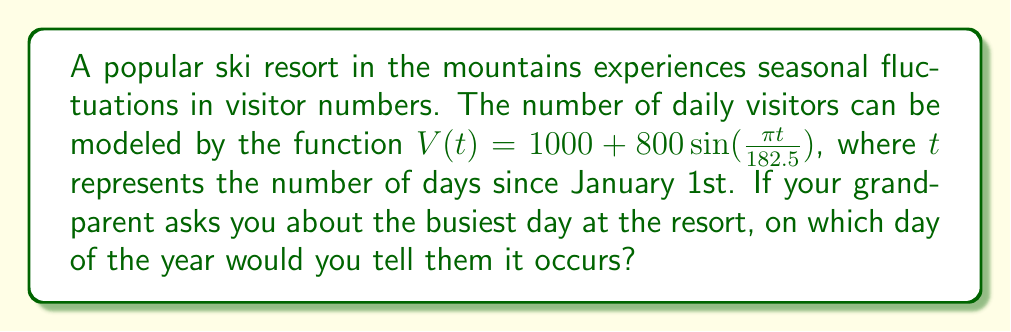Show me your answer to this math problem. To find the busiest day, we need to determine when the function $V(t)$ reaches its maximum value. Let's approach this step-by-step:

1) The sine function reaches its maximum value of 1 when its argument is $\frac{\pi}{2}$ (or 90 degrees).

2) We need to solve the equation: $\frac{\pi t}{182.5} = \frac{\pi}{2}$

3) Simplifying:
   $t = 182.5 \cdot \frac{1}{2} = 91.25$

4) This means the function reaches its maximum 91.25 days after January 1st.

5) To convert this to a calendar date:
   - January has 31 days
   - February has 28 days (assuming it's not a leap year)
   - March has 31 days
   - 31 + 28 + 31 = 90 days

6) The 91.25th day falls on April 1st (the 91st day of the year).

Therefore, the busiest day at the resort occurs on April 1st.
Answer: April 1st 